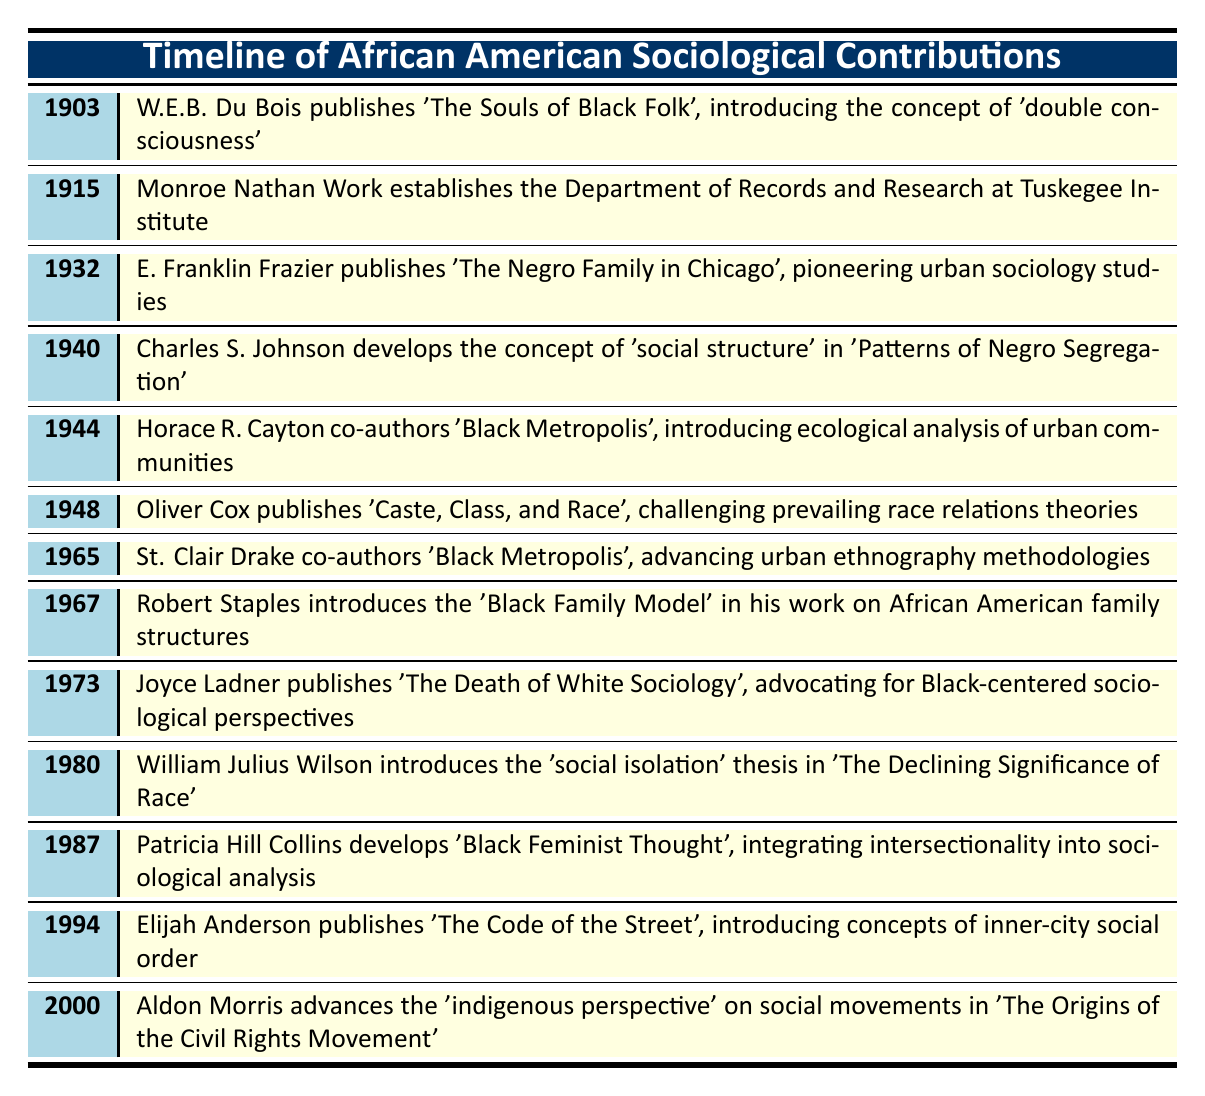What year did W.E.B. Du Bois publish 'The Souls of Black Folk'? The table states that W.E.B. Du Bois published 'The Souls of Black Folk' in 1903.
Answer: 1903 What concept did E. Franklin Frazier introduce in 1932? The table indicates that E. Franklin Frazier published 'The Negro Family in Chicago', which pioneered urban sociology studies.
Answer: Urban sociology In how many cases did sociologists publish works in the 1960s? From the table, there are two entries for the 1960s: Robert Staples in 1967 and St. Clair Drake in 1965, therefore there are 2 publications in the 1960s.
Answer: 2 Which sociologist's work in 1973 advocated for Black-centered sociological perspectives? According to the table, Joyce Ladner published 'The Death of White Sociology' in 1973, which supported Black-centered sociological perspectives.
Answer: Joyce Ladner Was 'Black Metropolis' co-authored by St. Clair Drake? The table shows that St. Clair Drake co-authored 'Black Metropolis' in 1965, indicating that the statement is true.
Answer: Yes What is the difference in years between the publication of 'The Souls of Black Folk' and 'Caste, Class, and Race'? 'The Souls of Black Folk' was published in 1903 and 'Caste, Class, and Race' in 1948. The difference is 1948 - 1903 = 45 years.
Answer: 45 years What was the central theme in the works published by African American sociologists between 1940 and 1980? Between 1940 and 1980, the table lists several works focusing on social structure, urban communities, family models, and social isolation, indicating a shift towards addressing systemic issues affecting African Americans.
Answer: Systemic issues Which sociologist advanced urban ethnography methodologies, and in what year? St. Clair Drake co-authored 'Black Metropolis' in 1965, as indicated in the table.
Answer: St. Clair Drake in 1965 How many years passed between the publication of the 'social isolation' thesis and 'Black Feminist Thought'? 'The social isolation' thesis was published in 1980, and 'Black Feminist Thought' was published in 1987. Therefore, the difference is 1987 - 1980 = 7 years.
Answer: 7 years 